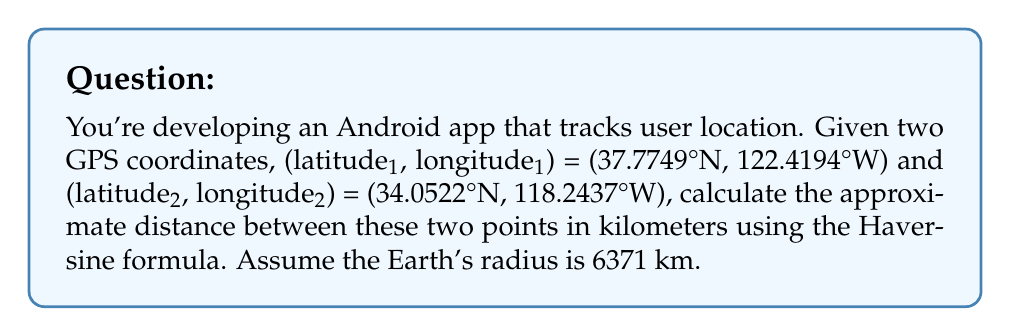Provide a solution to this math problem. To calculate the distance between two GPS coordinates, we'll use the Haversine formula. Here's a step-by-step explanation:

1. Convert latitudes and longitudes from degrees to radians:
   $\text{lat1} = 37.7749° \times \frac{\pi}{180} = 0.6593 \text{ rad}$
   $\text{lon1} = -122.4194° \times \frac{\pi}{180} = -2.1366 \text{ rad}$
   $\text{lat2} = 34.0522° \times \frac{\pi}{180} = 0.5942 \text{ rad}$
   $\text{lon2} = -118.2437° \times \frac{\pi}{180} = -2.0638 \text{ rad}$

2. Calculate the differences in latitude and longitude:
   $\Delta\text{lat} = \text{lat2} - \text{lat1} = -0.0651 \text{ rad}$
   $\Delta\text{lon} = \text{lon2} - \text{lon1} = 0.0728 \text{ rad}$

3. Apply the Haversine formula:
   $$a = \sin^2(\frac{\Delta\text{lat}}{2}) + \cos(\text{lat1}) \times \cos(\text{lat2}) \times \sin^2(\frac{\Delta\text{lon}}{2})$$
   $$c = 2 \times \arctan2(\sqrt{a}, \sqrt{1-a})$$
   $$d = R \times c$$

   Where R is the Earth's radius (6371 km).

4. Calculate the components:
   $\sin^2(\frac{\Delta\text{lat}}{2}) = 0.0011$
   $\cos(\text{lat1}) = 0.7916$
   $\cos(\text{lat2}) = 0.8292$
   $\sin^2(\frac{\Delta\text{lon}}{2}) = 0.0013$

5. Compute a:
   $a = 0.0011 + 0.7916 \times 0.8292 \times 0.0013 = 0.0021$

6. Calculate c:
   $c = 2 \times \arctan2(\sqrt{0.0021}, \sqrt{1-0.0021}) = 0.0917$

7. Finally, calculate the distance:
   $d = 6371 \times 0.0917 = 584.22 \text{ km}$
Answer: 584.22 km 